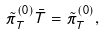<formula> <loc_0><loc_0><loc_500><loc_500>\tilde { \pi } _ { T } ^ { ( 0 ) } \bar { T } = \tilde { \pi } _ { T } ^ { ( 0 ) } ,</formula> 